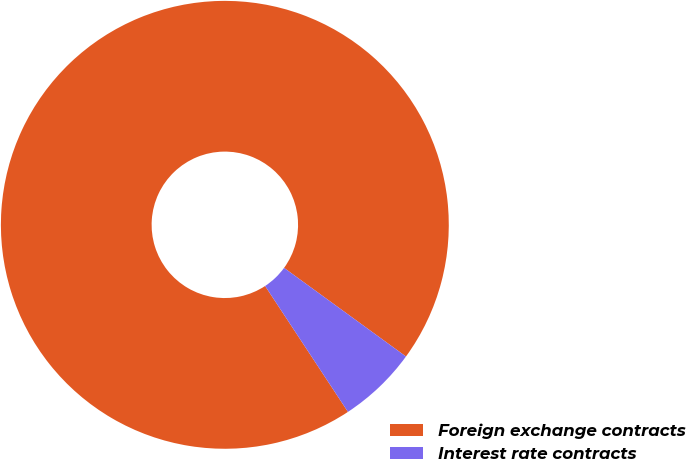Convert chart. <chart><loc_0><loc_0><loc_500><loc_500><pie_chart><fcel>Foreign exchange contracts<fcel>Interest rate contracts<nl><fcel>94.27%<fcel>5.73%<nl></chart> 